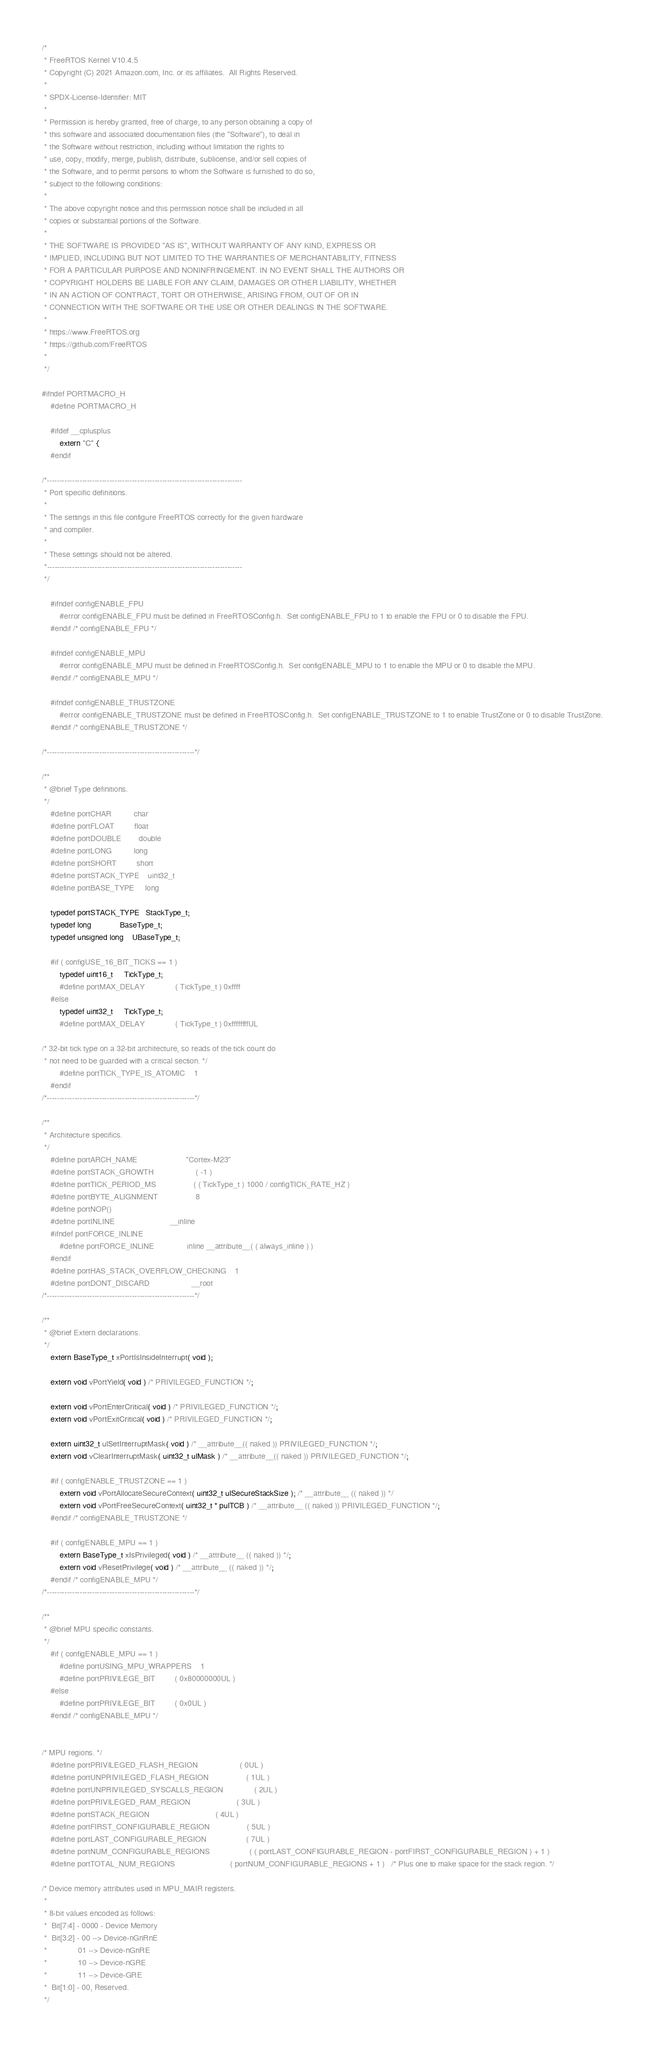<code> <loc_0><loc_0><loc_500><loc_500><_C_>/*
 * FreeRTOS Kernel V10.4.5
 * Copyright (C) 2021 Amazon.com, Inc. or its affiliates.  All Rights Reserved.
 *
 * SPDX-License-Identifier: MIT
 *
 * Permission is hereby granted, free of charge, to any person obtaining a copy of
 * this software and associated documentation files (the "Software"), to deal in
 * the Software without restriction, including without limitation the rights to
 * use, copy, modify, merge, publish, distribute, sublicense, and/or sell copies of
 * the Software, and to permit persons to whom the Software is furnished to do so,
 * subject to the following conditions:
 *
 * The above copyright notice and this permission notice shall be included in all
 * copies or substantial portions of the Software.
 *
 * THE SOFTWARE IS PROVIDED "AS IS", WITHOUT WARRANTY OF ANY KIND, EXPRESS OR
 * IMPLIED, INCLUDING BUT NOT LIMITED TO THE WARRANTIES OF MERCHANTABILITY, FITNESS
 * FOR A PARTICULAR PURPOSE AND NONINFRINGEMENT. IN NO EVENT SHALL THE AUTHORS OR
 * COPYRIGHT HOLDERS BE LIABLE FOR ANY CLAIM, DAMAGES OR OTHER LIABILITY, WHETHER
 * IN AN ACTION OF CONTRACT, TORT OR OTHERWISE, ARISING FROM, OUT OF OR IN
 * CONNECTION WITH THE SOFTWARE OR THE USE OR OTHER DEALINGS IN THE SOFTWARE.
 *
 * https://www.FreeRTOS.org
 * https://github.com/FreeRTOS
 *
 */

#ifndef PORTMACRO_H
    #define PORTMACRO_H

    #ifdef __cplusplus
        extern "C" {
    #endif

/*------------------------------------------------------------------------------
 * Port specific definitions.
 *
 * The settings in this file configure FreeRTOS correctly for the given hardware
 * and compiler.
 *
 * These settings should not be altered.
 *------------------------------------------------------------------------------
 */

    #ifndef configENABLE_FPU
        #error configENABLE_FPU must be defined in FreeRTOSConfig.h.  Set configENABLE_FPU to 1 to enable the FPU or 0 to disable the FPU.
    #endif /* configENABLE_FPU */

    #ifndef configENABLE_MPU
        #error configENABLE_MPU must be defined in FreeRTOSConfig.h.  Set configENABLE_MPU to 1 to enable the MPU or 0 to disable the MPU.
    #endif /* configENABLE_MPU */

    #ifndef configENABLE_TRUSTZONE
        #error configENABLE_TRUSTZONE must be defined in FreeRTOSConfig.h.  Set configENABLE_TRUSTZONE to 1 to enable TrustZone or 0 to disable TrustZone.
    #endif /* configENABLE_TRUSTZONE */

/*-----------------------------------------------------------*/

/**
 * @brief Type definitions.
 */
    #define portCHAR          char
    #define portFLOAT         float
    #define portDOUBLE        double
    #define portLONG          long
    #define portSHORT         short
    #define portSTACK_TYPE    uint32_t
    #define portBASE_TYPE     long

    typedef portSTACK_TYPE   StackType_t;
    typedef long             BaseType_t;
    typedef unsigned long    UBaseType_t;

    #if ( configUSE_16_BIT_TICKS == 1 )
        typedef uint16_t     TickType_t;
        #define portMAX_DELAY              ( TickType_t ) 0xffff
    #else
        typedef uint32_t     TickType_t;
        #define portMAX_DELAY              ( TickType_t ) 0xffffffffUL

/* 32-bit tick type on a 32-bit architecture, so reads of the tick count do
 * not need to be guarded with a critical section. */
        #define portTICK_TYPE_IS_ATOMIC    1
    #endif
/*-----------------------------------------------------------*/

/**
 * Architecture specifics.
 */
    #define portARCH_NAME                      "Cortex-M23"
    #define portSTACK_GROWTH                   ( -1 )
    #define portTICK_PERIOD_MS                 ( ( TickType_t ) 1000 / configTICK_RATE_HZ )
    #define portBYTE_ALIGNMENT                 8
    #define portNOP()
    #define portINLINE                         __inline
    #ifndef portFORCE_INLINE
        #define portFORCE_INLINE               inline __attribute__( ( always_inline ) )
    #endif
    #define portHAS_STACK_OVERFLOW_CHECKING    1
    #define portDONT_DISCARD                   __root
/*-----------------------------------------------------------*/

/**
 * @brief Extern declarations.
 */
    extern BaseType_t xPortIsInsideInterrupt( void );

    extern void vPortYield( void ) /* PRIVILEGED_FUNCTION */;

    extern void vPortEnterCritical( void ) /* PRIVILEGED_FUNCTION */;
    extern void vPortExitCritical( void ) /* PRIVILEGED_FUNCTION */;

    extern uint32_t ulSetInterruptMask( void ) /* __attribute__(( naked )) PRIVILEGED_FUNCTION */;
    extern void vClearInterruptMask( uint32_t ulMask ) /* __attribute__(( naked )) PRIVILEGED_FUNCTION */;

    #if ( configENABLE_TRUSTZONE == 1 )
        extern void vPortAllocateSecureContext( uint32_t ulSecureStackSize ); /* __attribute__ (( naked )) */
        extern void vPortFreeSecureContext( uint32_t * pulTCB ) /* __attribute__ (( naked )) PRIVILEGED_FUNCTION */;
    #endif /* configENABLE_TRUSTZONE */

    #if ( configENABLE_MPU == 1 )
        extern BaseType_t xIsPrivileged( void ) /* __attribute__ (( naked )) */;
        extern void vResetPrivilege( void ) /* __attribute__ (( naked )) */;
    #endif /* configENABLE_MPU */
/*-----------------------------------------------------------*/

/**
 * @brief MPU specific constants.
 */
    #if ( configENABLE_MPU == 1 )
        #define portUSING_MPU_WRAPPERS    1
        #define portPRIVILEGE_BIT         ( 0x80000000UL )
    #else
        #define portPRIVILEGE_BIT         ( 0x0UL )
    #endif /* configENABLE_MPU */


/* MPU regions. */
    #define portPRIVILEGED_FLASH_REGION                   ( 0UL )
    #define portUNPRIVILEGED_FLASH_REGION                 ( 1UL )
    #define portUNPRIVILEGED_SYSCALLS_REGION              ( 2UL )
    #define portPRIVILEGED_RAM_REGION                     ( 3UL )
    #define portSTACK_REGION                              ( 4UL )
    #define portFIRST_CONFIGURABLE_REGION                 ( 5UL )
    #define portLAST_CONFIGURABLE_REGION                  ( 7UL )
    #define portNUM_CONFIGURABLE_REGIONS                  ( ( portLAST_CONFIGURABLE_REGION - portFIRST_CONFIGURABLE_REGION ) + 1 )
    #define portTOTAL_NUM_REGIONS                         ( portNUM_CONFIGURABLE_REGIONS + 1 )   /* Plus one to make space for the stack region. */

/* Device memory attributes used in MPU_MAIR registers.
 *
 * 8-bit values encoded as follows:
 *  Bit[7:4] - 0000 - Device Memory
 *  Bit[3:2] - 00 --> Device-nGnRnE
 *				01 --> Device-nGnRE
 *				10 --> Device-nGRE
 *				11 --> Device-GRE
 *  Bit[1:0] - 00, Reserved.
 */</code> 